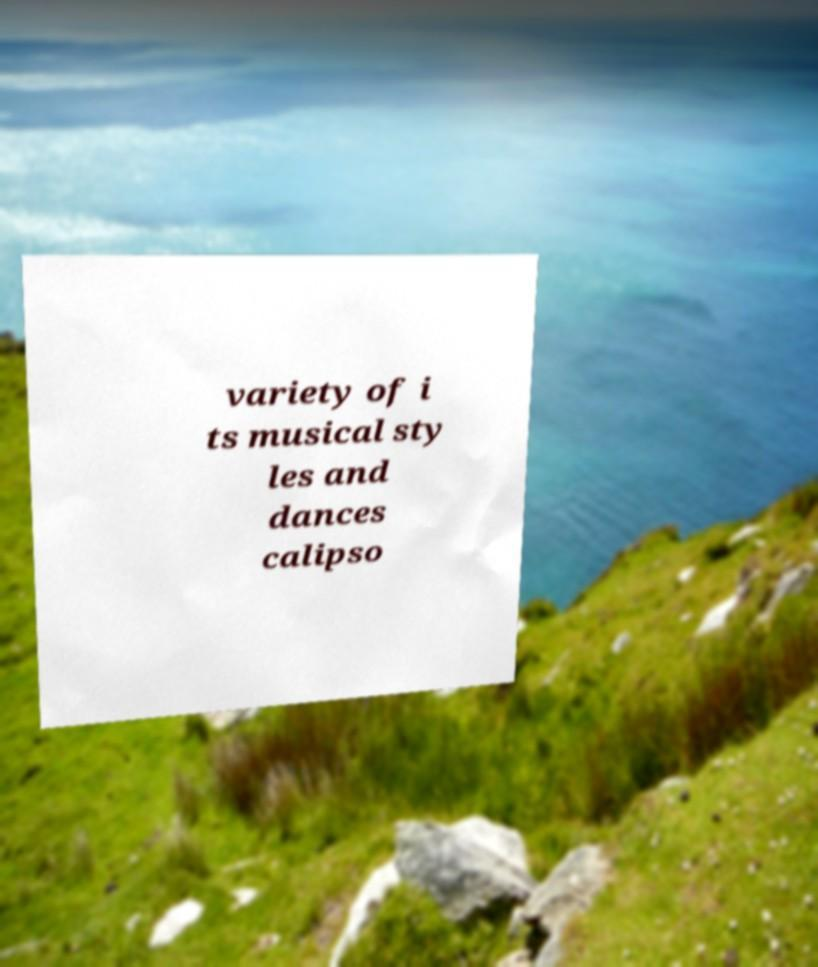Can you read and provide the text displayed in the image?This photo seems to have some interesting text. Can you extract and type it out for me? variety of i ts musical sty les and dances calipso 